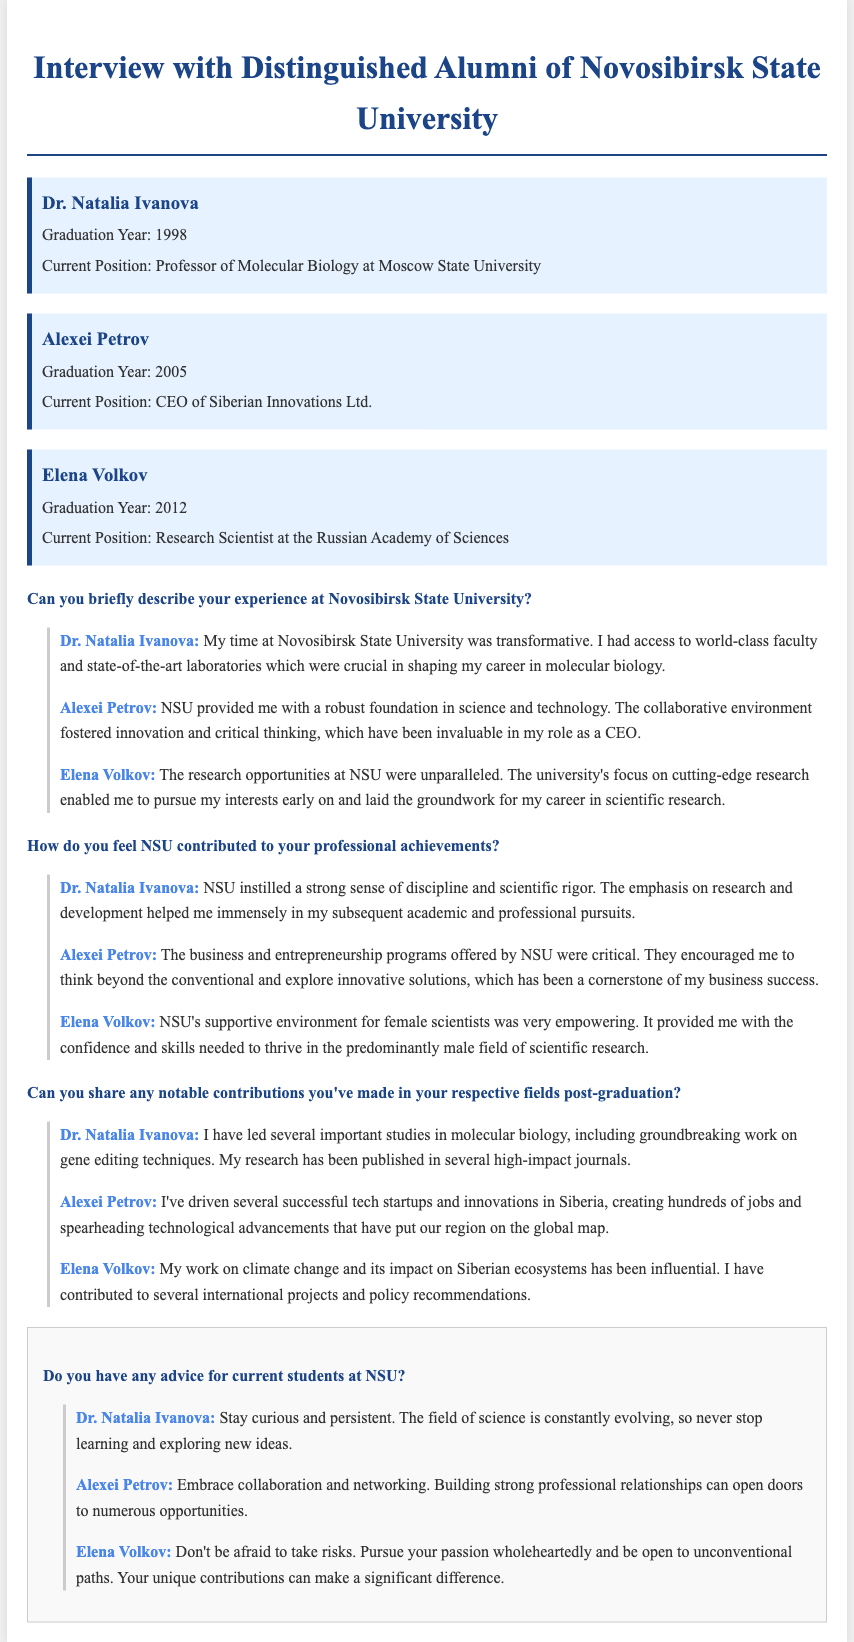What is the graduation year of Dr. Natalia Ivanova? The document states that Dr. Natalia Ivanova graduated in 1998.
Answer: 1998 What is Alexei Petrov's current position? The document indicates that Alexei Petrov is the CEO of Siberian Innovations Ltd.
Answer: CEO of Siberian Innovations Ltd What notable contribution did Elena Volkov make post-graduation? The document mentions that Elena Volkov's work on climate change has been influential.
Answer: Climate change What advice does Dr. Natalia Ivanova give to current students at NSU? Dr. Natalia Ivanova advises students to stay curious and persistent.
Answer: Stay curious and persistent What year did Elena Volkov graduate? The document records that Elena Volkov graduated in 2012.
Answer: 2012 What is the common theme in the experiences shared by the alumni about NSU? The common theme highlighted is the supportive environment and research opportunities at NSU.
Answer: Supportive environment and research opportunities What field does Dr. Natalia Ivanova specialize in? The document states that she is a Professor of Molecular Biology.
Answer: Molecular Biology How did NSU help Alexei Petrov in his career? Alexei Petrov mentions that NSU's entrepreneurship programs were critical for his business success.
Answer: Entrepreneurship programs What is the focus of Elena Volkov's research? The document outlines that Elena Volkov’s research focuses on Siberian ecosystems and climate change.
Answer: Siberian ecosystems and climate change 